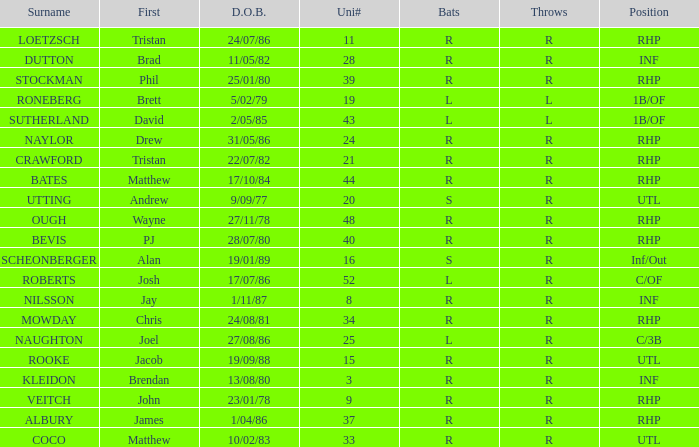Which Position has a Surname of naylor? RHP. Could you help me parse every detail presented in this table? {'header': ['Surname', 'First', 'D.O.B.', 'Uni#', 'Bats', 'Throws', 'Position'], 'rows': [['LOETZSCH', 'Tristan', '24/07/86', '11', 'R', 'R', 'RHP'], ['DUTTON', 'Brad', '11/05/82', '28', 'R', 'R', 'INF'], ['STOCKMAN', 'Phil', '25/01/80', '39', 'R', 'R', 'RHP'], ['RONEBERG', 'Brett', '5/02/79', '19', 'L', 'L', '1B/OF'], ['SUTHERLAND', 'David', '2/05/85', '43', 'L', 'L', '1B/OF'], ['NAYLOR', 'Drew', '31/05/86', '24', 'R', 'R', 'RHP'], ['CRAWFORD', 'Tristan', '22/07/82', '21', 'R', 'R', 'RHP'], ['BATES', 'Matthew', '17/10/84', '44', 'R', 'R', 'RHP'], ['UTTING', 'Andrew', '9/09/77', '20', 'S', 'R', 'UTL'], ['OUGH', 'Wayne', '27/11/78', '48', 'R', 'R', 'RHP'], ['BEVIS', 'PJ', '28/07/80', '40', 'R', 'R', 'RHP'], ['SCHEONBERGER', 'Alan', '19/01/89', '16', 'S', 'R', 'Inf/Out'], ['ROBERTS', 'Josh', '17/07/86', '52', 'L', 'R', 'C/OF'], ['NILSSON', 'Jay', '1/11/87', '8', 'R', 'R', 'INF'], ['MOWDAY', 'Chris', '24/08/81', '34', 'R', 'R', 'RHP'], ['NAUGHTON', 'Joel', '27/08/86', '25', 'L', 'R', 'C/3B'], ['ROOKE', 'Jacob', '19/09/88', '15', 'R', 'R', 'UTL'], ['KLEIDON', 'Brendan', '13/08/80', '3', 'R', 'R', 'INF'], ['VEITCH', 'John', '23/01/78', '9', 'R', 'R', 'RHP'], ['ALBURY', 'James', '1/04/86', '37', 'R', 'R', 'RHP'], ['COCO', 'Matthew', '10/02/83', '33', 'R', 'R', 'UTL']]} 